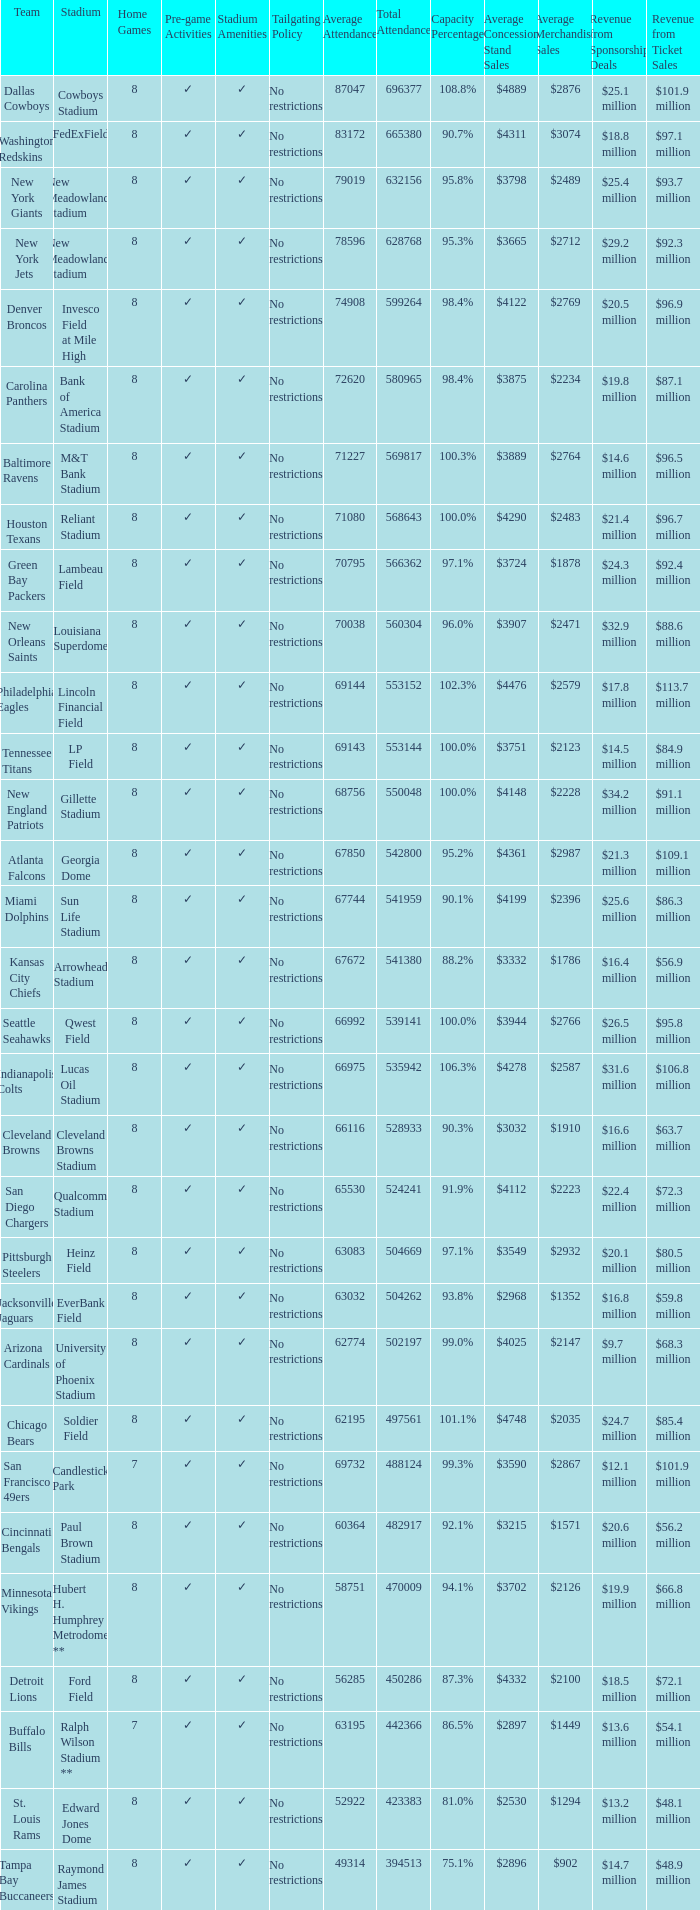What team held a 102.3% capacity? Philadelphia Eagles. 